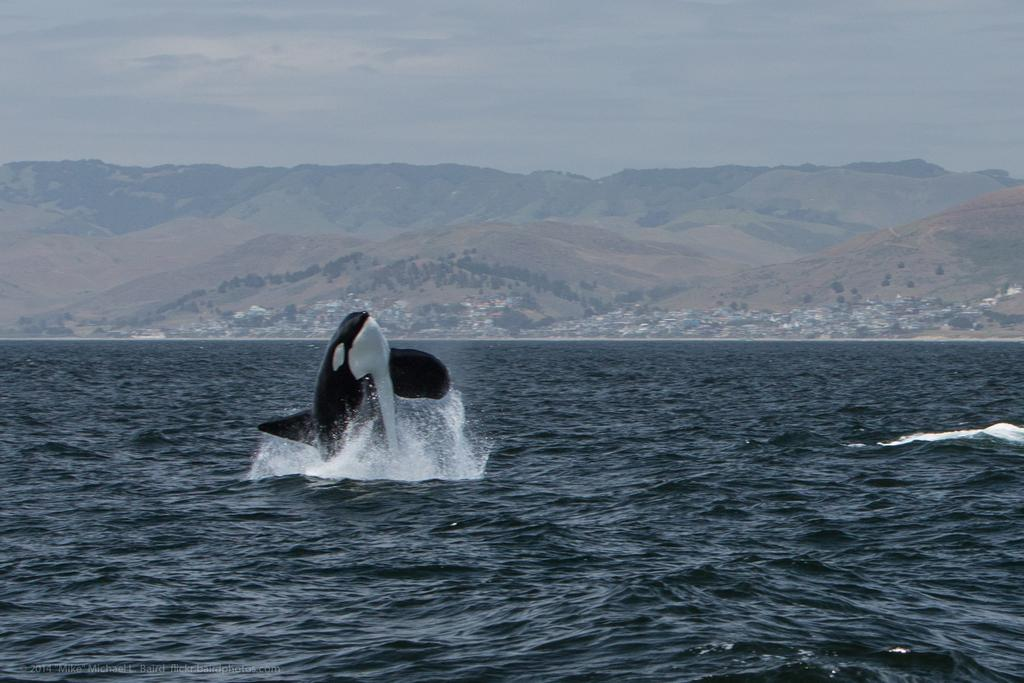What animal can be seen in the image? There is a dolphin in the image. What is the dolphin doing in the image? The dolphin is coming out of the water in the image. What can be seen in the background of the image? There are hills, houses, and trees in the background of the image. How many minutes does it take for the dolphin to jump out of the water in the image? The image is a still photograph, so it does not show the passage of time or the duration of the dolphin's jump. Therefore, it is not possible to determine how many minutes it takes for the dolphin to jump out of the water in the image. 